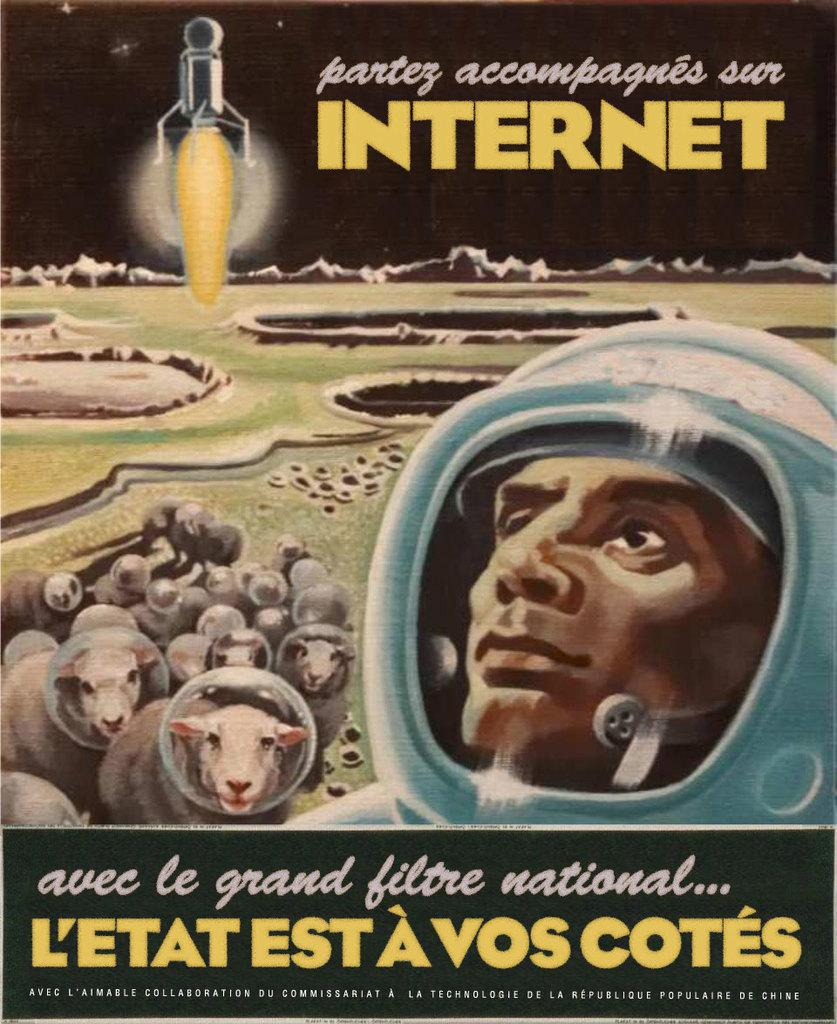Provide a one-sentence caption for the provided image. A book with a man and sheep on it called Partez accompagnes sur Internet. 